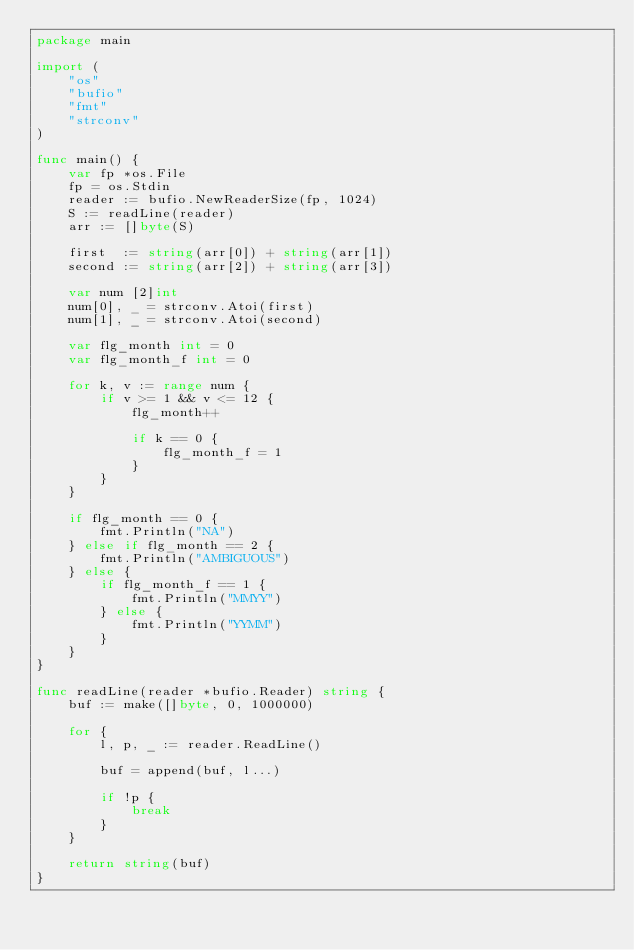Convert code to text. <code><loc_0><loc_0><loc_500><loc_500><_Go_>package main

import (
    "os"
    "bufio"
    "fmt"
    "strconv"
)

func main() {
    var fp *os.File
    fp = os.Stdin
    reader := bufio.NewReaderSize(fp, 1024)
    S := readLine(reader)
    arr := []byte(S)

    first  := string(arr[0]) + string(arr[1])
    second := string(arr[2]) + string(arr[3])

    var num [2]int
    num[0], _ = strconv.Atoi(first)
    num[1], _ = strconv.Atoi(second)

    var flg_month int = 0
    var flg_month_f int = 0

    for k, v := range num {
        if v >= 1 && v <= 12 {
            flg_month++

            if k == 0 {
                flg_month_f = 1
            }
        }
    }

    if flg_month == 0 {
        fmt.Println("NA")
    } else if flg_month == 2 {
        fmt.Println("AMBIGUOUS")
    } else {
        if flg_month_f == 1 {
            fmt.Println("MMYY")
        } else {
            fmt.Println("YYMM")
        }
    }
}

func readLine(reader *bufio.Reader) string {
    buf := make([]byte, 0, 1000000)

    for {
        l, p, _ := reader.ReadLine()

        buf = append(buf, l...)

        if !p {
            break
        }
    }

    return string(buf)
}</code> 